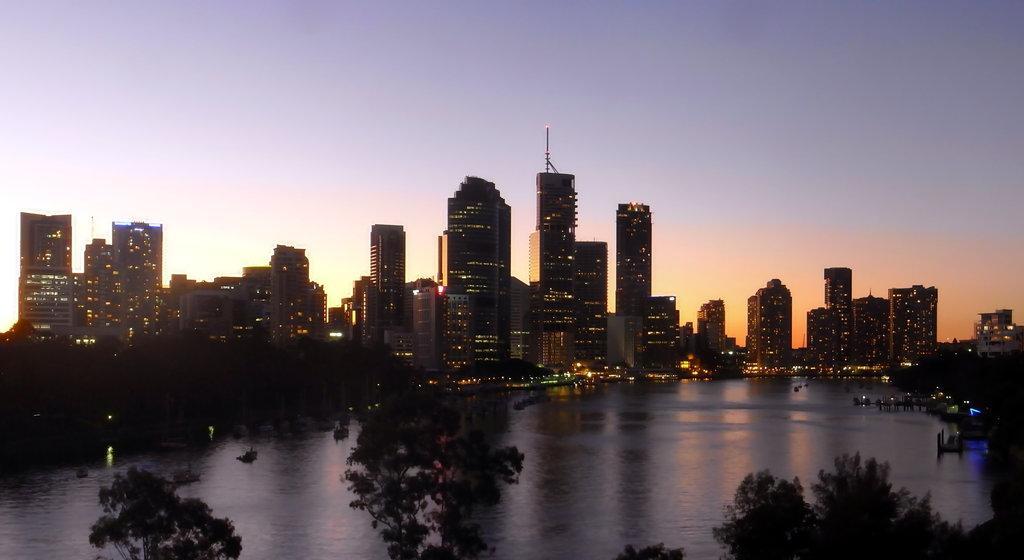Could you give a brief overview of what you see in this image? In this image there is the water. In the background there are buildings and skyscrapers. At the top there is the sky. At the bottom there are trees. 